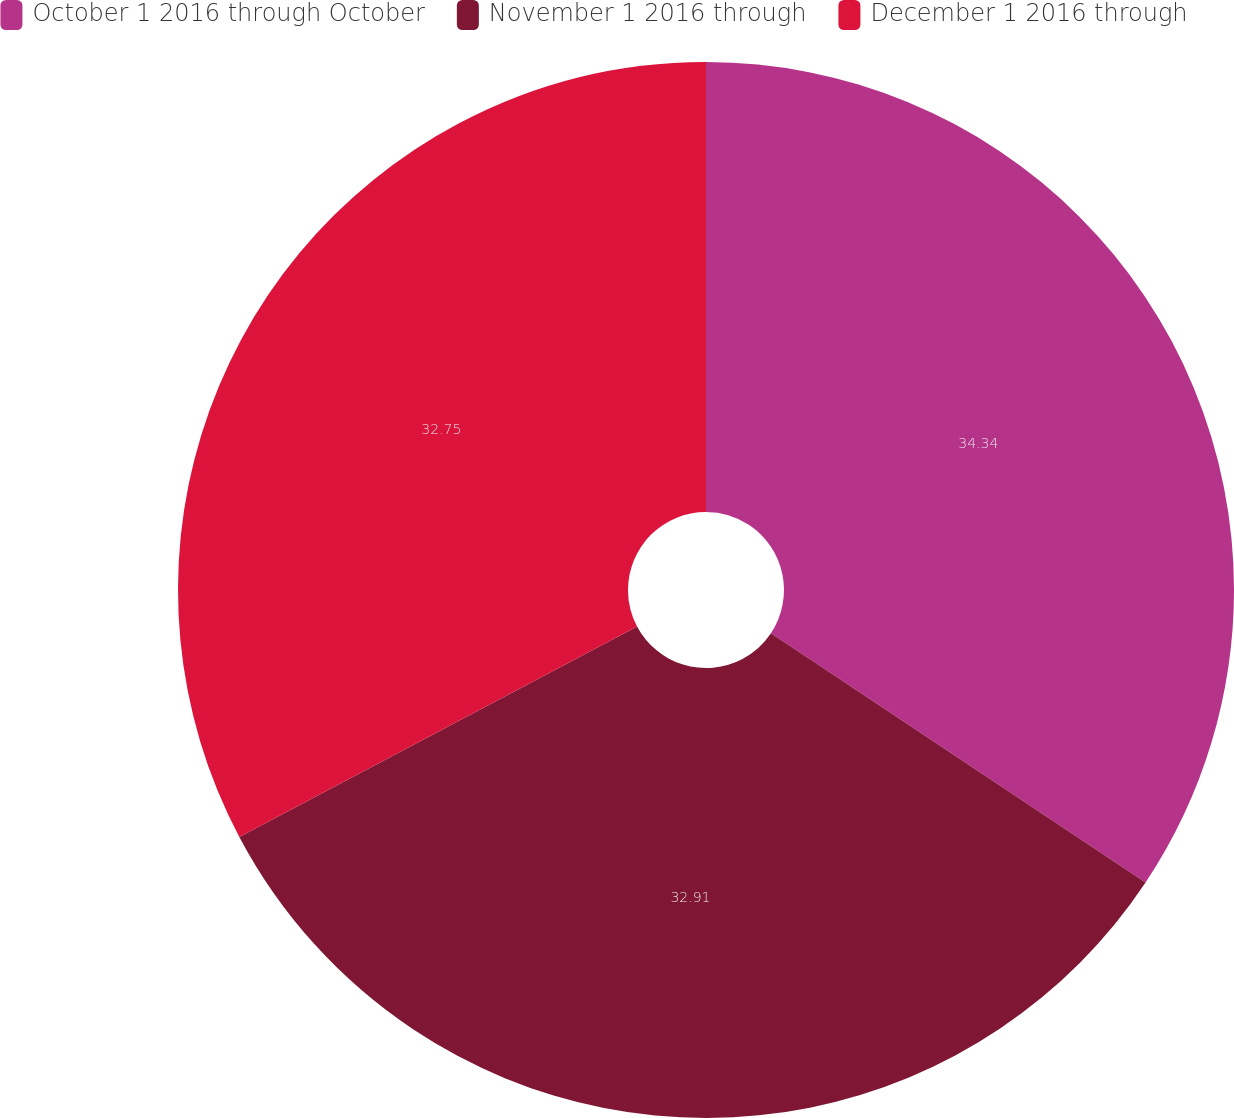Convert chart. <chart><loc_0><loc_0><loc_500><loc_500><pie_chart><fcel>October 1 2016 through October<fcel>November 1 2016 through<fcel>December 1 2016 through<nl><fcel>34.35%<fcel>32.91%<fcel>32.75%<nl></chart> 